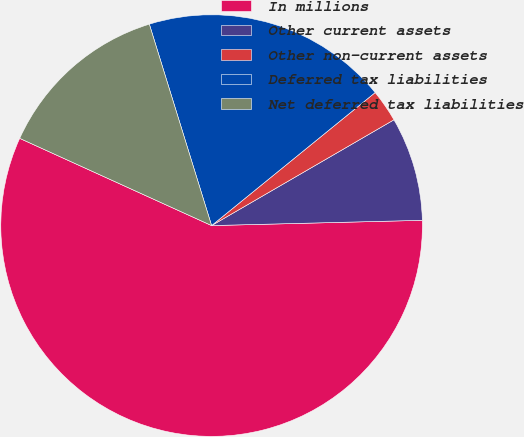<chart> <loc_0><loc_0><loc_500><loc_500><pie_chart><fcel>In millions<fcel>Other current assets<fcel>Other non-current assets<fcel>Deferred tax liabilities<fcel>Net deferred tax liabilities<nl><fcel>57.2%<fcel>7.97%<fcel>2.5%<fcel>18.91%<fcel>13.44%<nl></chart> 